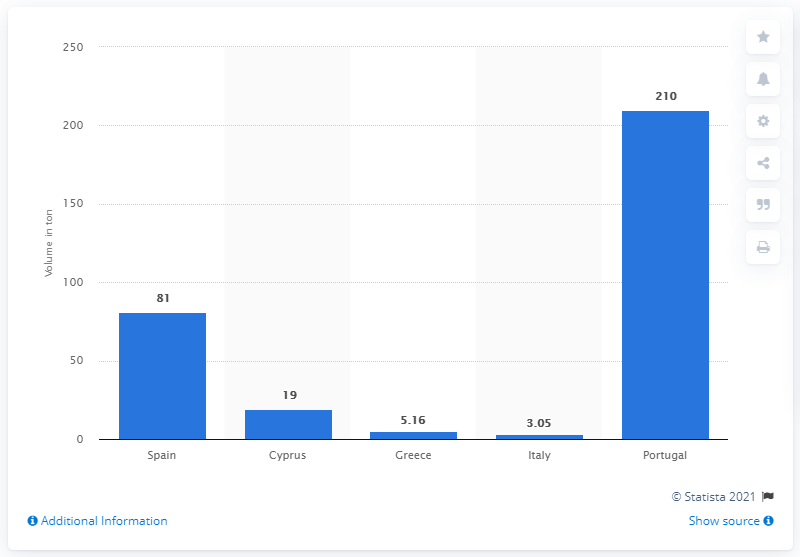Identify some key points in this picture. Portugal is significantly higher than Cyprus by a percentage of 191. Greece produces an average of 5.16 tons of grape fruit per year. Spain was the country that produced the most grapefruit in the 2018/2019 season. 